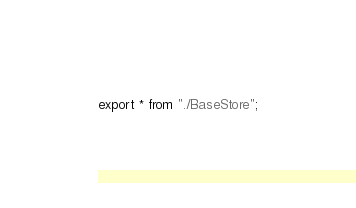<code> <loc_0><loc_0><loc_500><loc_500><_TypeScript_>export * from "./BaseStore";</code> 